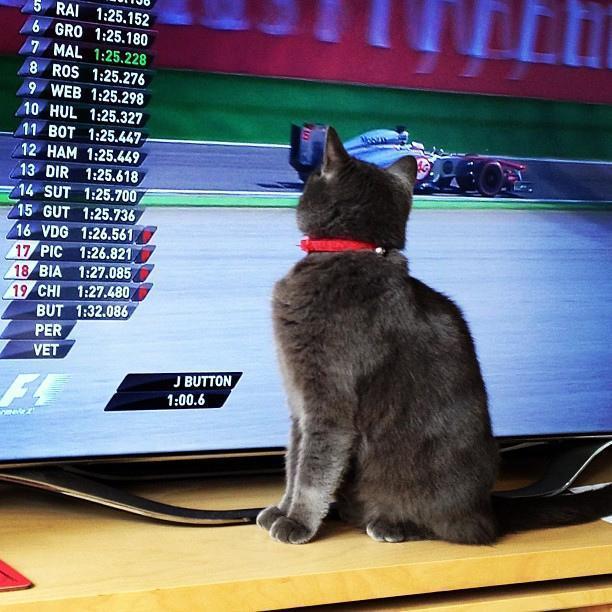How many backpacks in this picture?
Give a very brief answer. 0. 